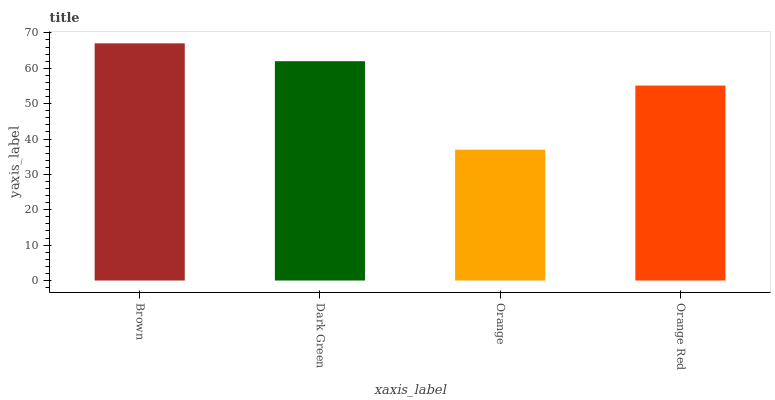Is Dark Green the minimum?
Answer yes or no. No. Is Dark Green the maximum?
Answer yes or no. No. Is Brown greater than Dark Green?
Answer yes or no. Yes. Is Dark Green less than Brown?
Answer yes or no. Yes. Is Dark Green greater than Brown?
Answer yes or no. No. Is Brown less than Dark Green?
Answer yes or no. No. Is Dark Green the high median?
Answer yes or no. Yes. Is Orange Red the low median?
Answer yes or no. Yes. Is Orange the high median?
Answer yes or no. No. Is Dark Green the low median?
Answer yes or no. No. 